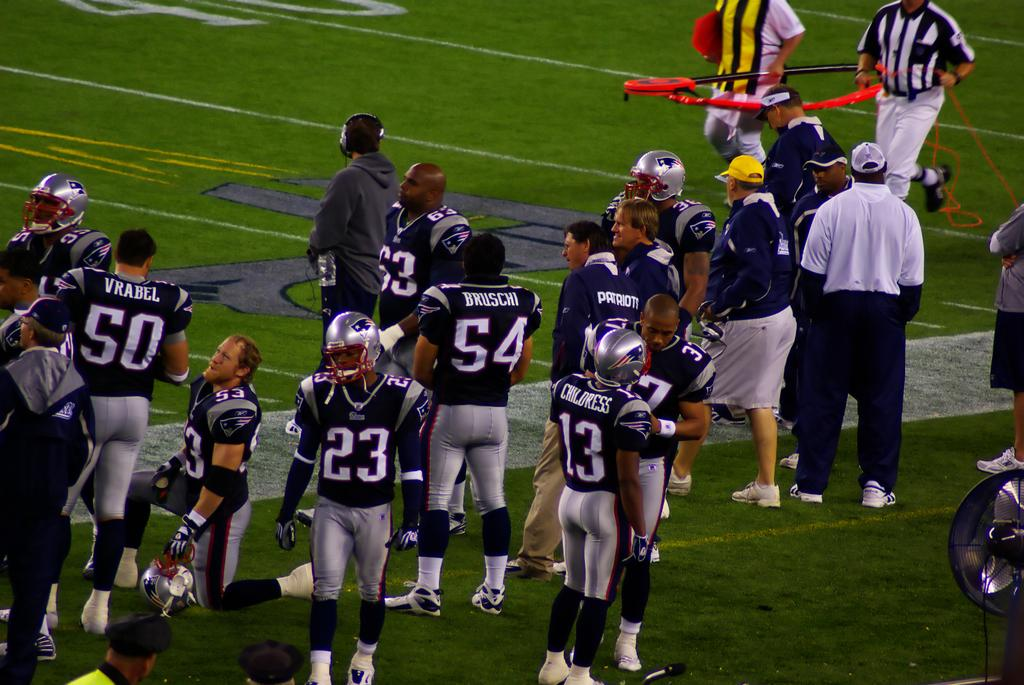What are the people in the image doing? The people in the image are standing and walking. Can you describe the object on the bottom right of the image? The object on the bottom right of the image is black in color. What type of surface is visible on the ground in the image? There is grass on the ground in the image. What type of root can be seen growing from the object on the bottom right of the image? There is no root visible in the image, as the object is not a plant or a living organism. 